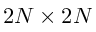<formula> <loc_0><loc_0><loc_500><loc_500>2 N \times 2 N</formula> 